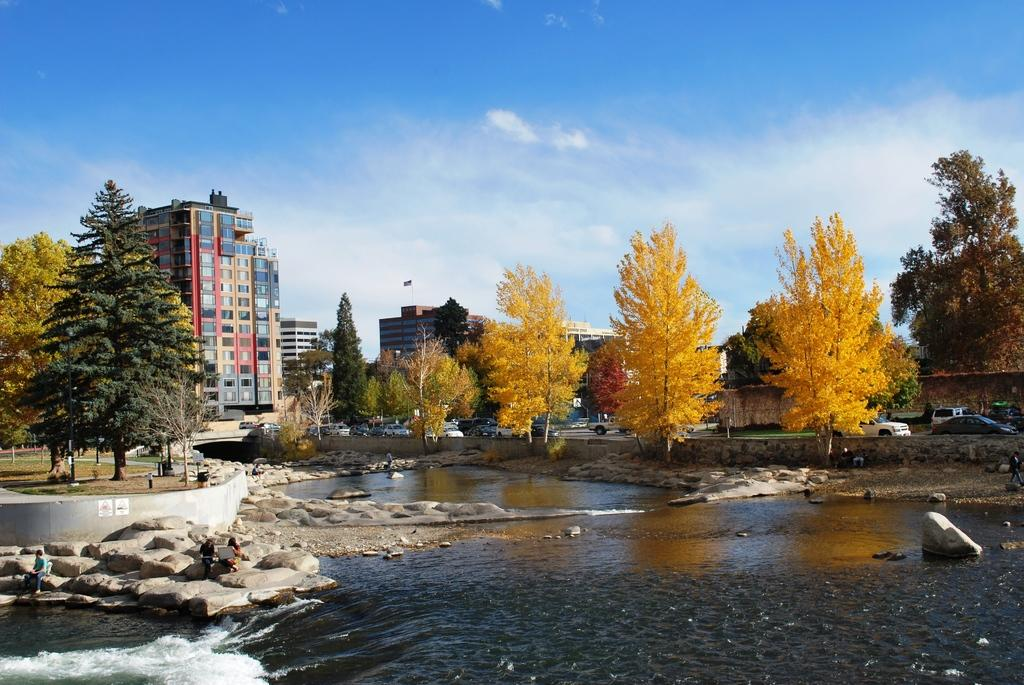What type of structures can be seen in the image? There are buildings in the image. What natural elements are present in the image? There are trees and water visible in the image. What type of terrain is depicted in the image? There are rocks in the image, suggesting a rocky terrain. What can be seen on the right side of the image? Vehicles are present on the right side of the image. What is visible in the background of the image? The sky is visible in the background of the image. Where is the farmer standing with the hen in the middle of the image? There is no farmer or hen present in the image. What type of animal is interacting with the rocks in the middle of the image? There is no animal interacting with the rocks in the image; only vehicles are present on the right side. 